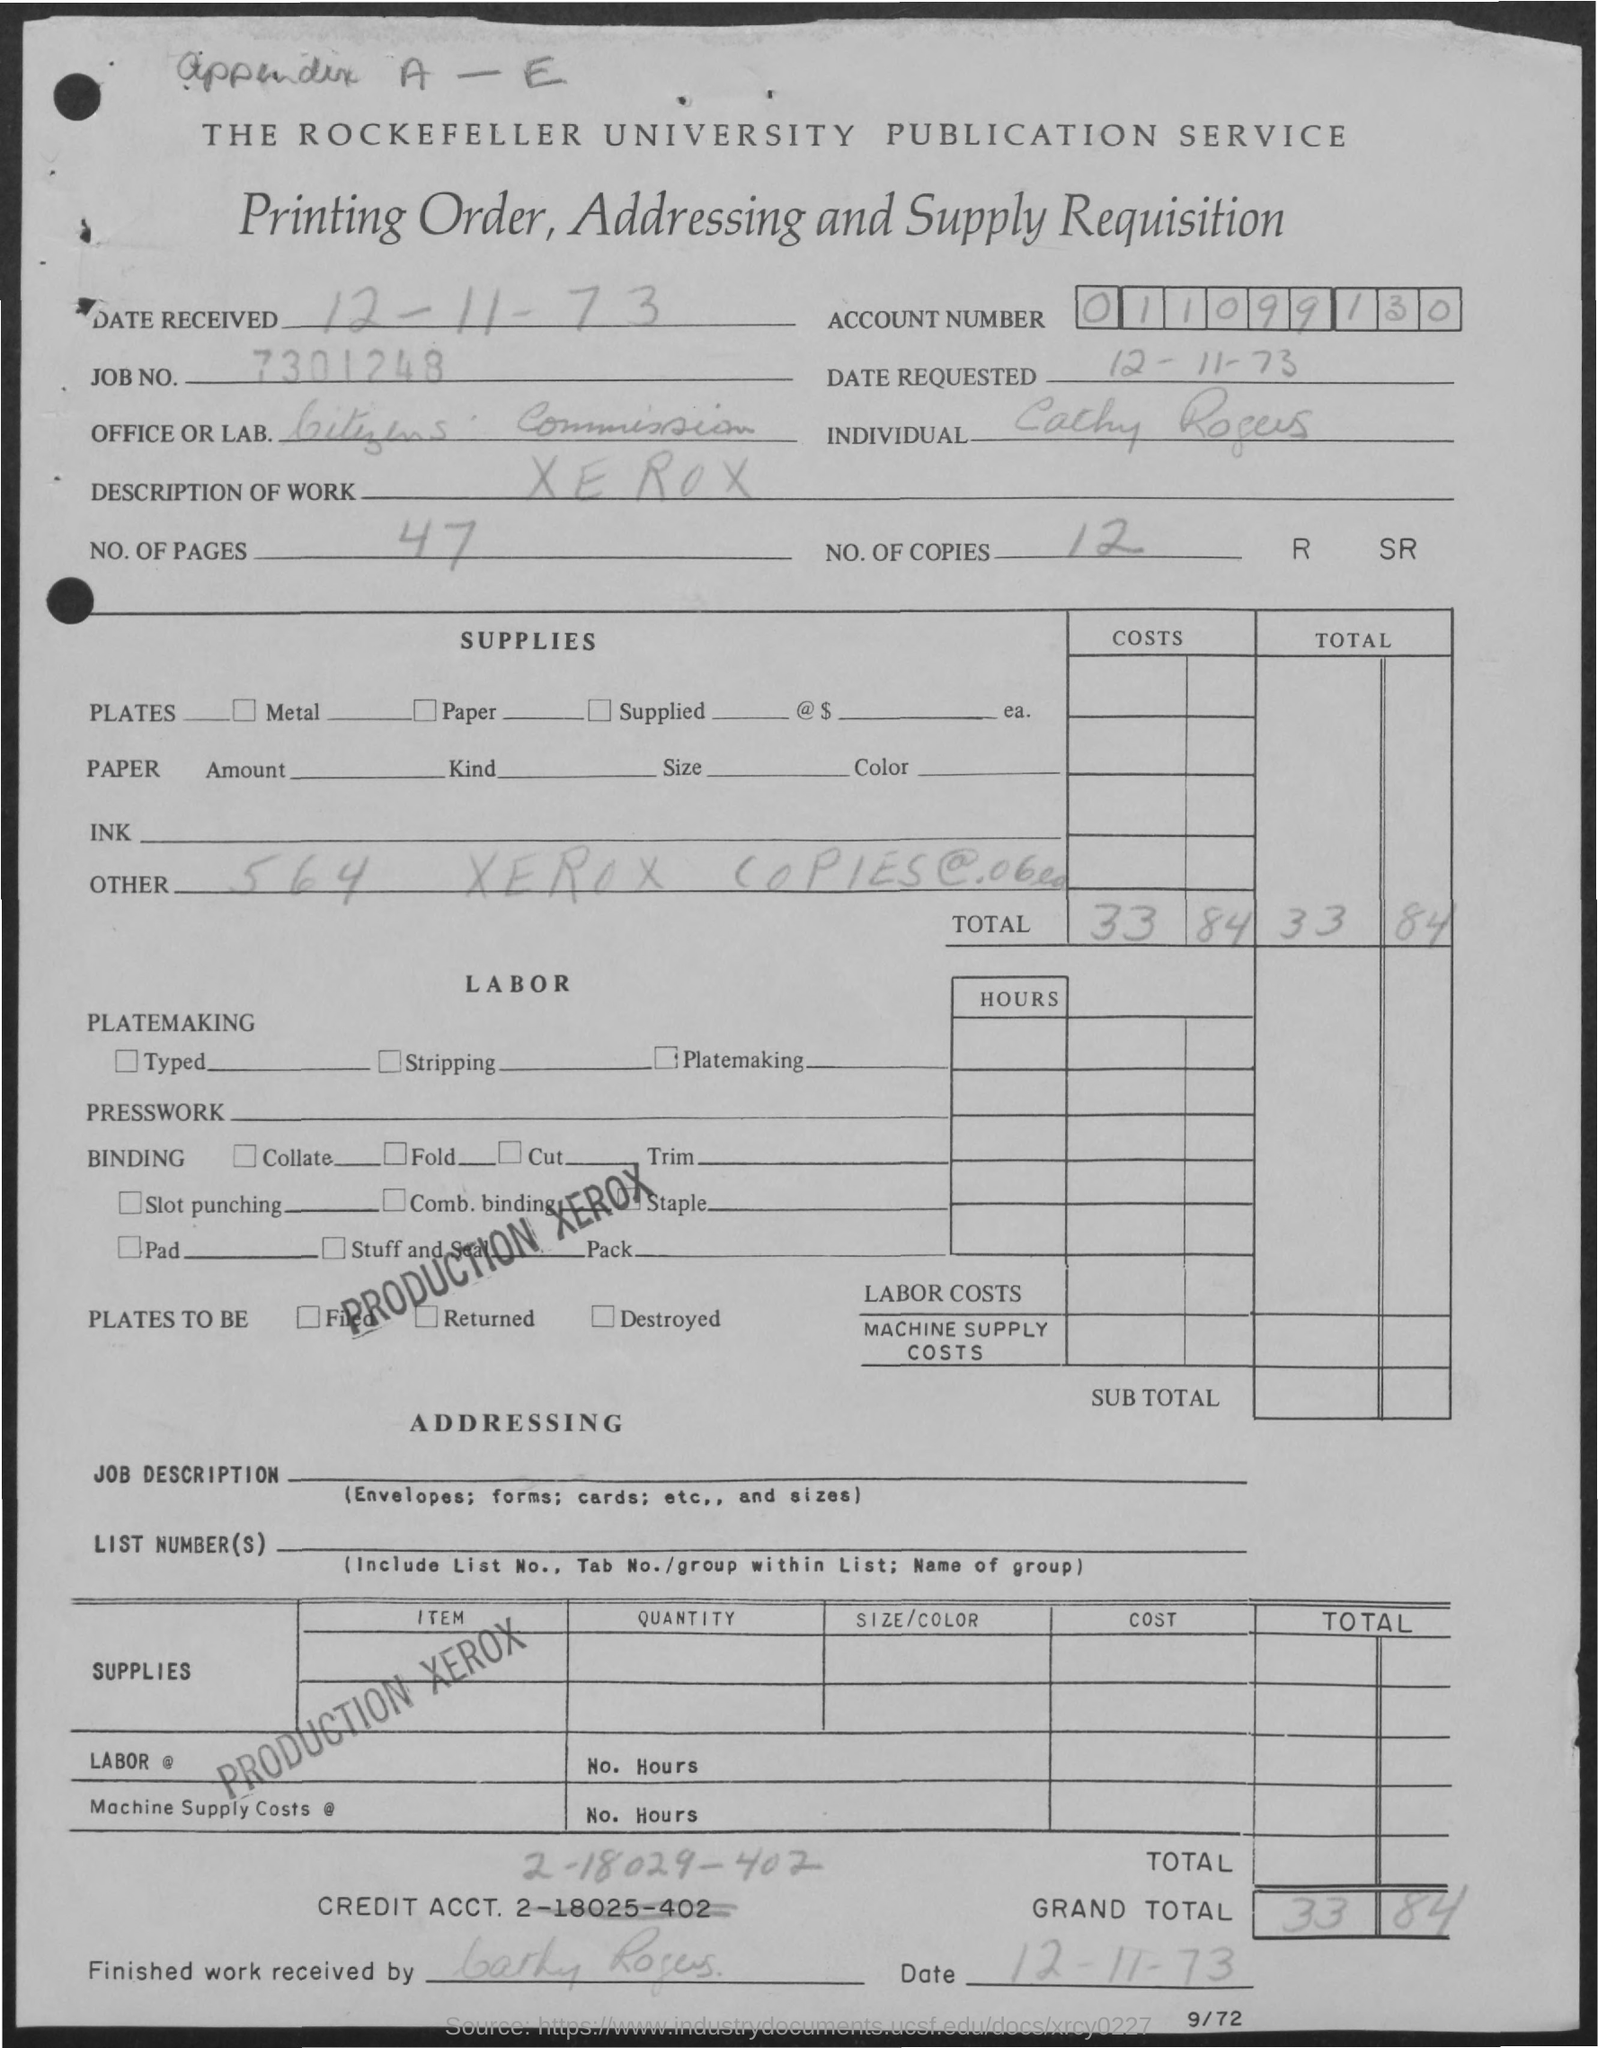What is the account number mentioned in the given page ?
Keep it short and to the point. 011099130. What is the job no. mentioned in the given page ?
Provide a succinct answer. 7301248. What is the description of work given in the page ?
Your answer should be compact. Xerox. How many no. of pages are mentioned in the given order ?
Keep it short and to the point. 47. How many no. of copies are mentioned in the given page ?
Give a very brief answer. 12. What is the name of office or lab as mentioned in the given page ?
Ensure brevity in your answer.  Citizens commission. What is the value of grand total mentioned in the given page ?
Offer a very short reply. 33.84. 